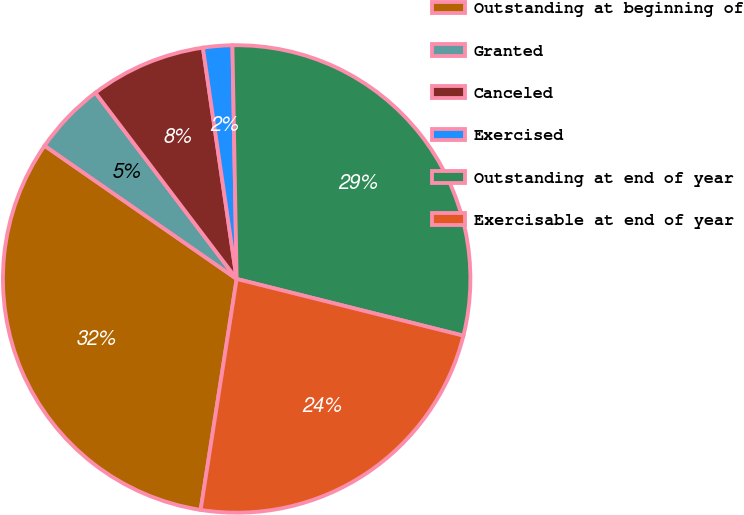Convert chart. <chart><loc_0><loc_0><loc_500><loc_500><pie_chart><fcel>Outstanding at beginning of<fcel>Granted<fcel>Canceled<fcel>Exercised<fcel>Outstanding at end of year<fcel>Exercisable at end of year<nl><fcel>32.19%<fcel>5.02%<fcel>8.02%<fcel>2.02%<fcel>29.19%<fcel>23.56%<nl></chart> 